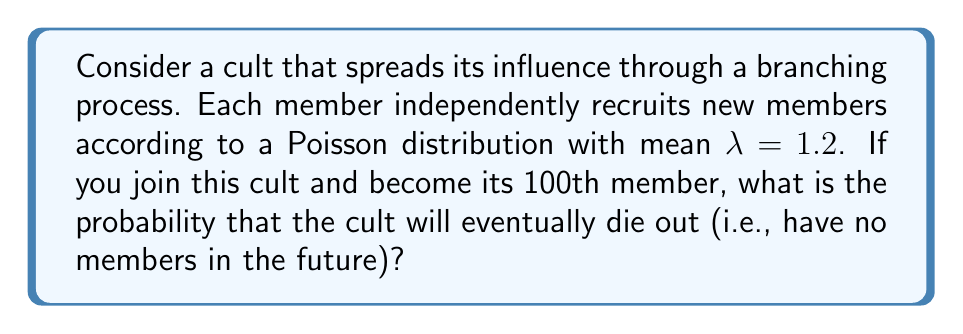Could you help me with this problem? To solve this problem, we'll use the theory of branching processes:

1) In a branching process, the probability of extinction is given by the smallest non-negative root of the equation:
   
   $$f(s) = G(s)$$

   where $G(s)$ is the probability generating function of the offspring distribution.

2) For a Poisson distribution with mean $\lambda$, the probability generating function is:
   
   $$G(s) = e^{\lambda(s-1)}$$

3) Therefore, we need to solve:
   
   $$s = e^{\lambda(s-1)}$$

4) With $\lambda = 1.2$, we have:
   
   $$s = e^{1.2(s-1)}$$

5) This equation can't be solved analytically, so we need to use numerical methods. Using a computer or calculator, we find that the smallest non-negative root is approximately:
   
   $$s \approx 0.7554$$

6) This value represents the probability that a single member's lineage will eventually die out.

7) However, the question asks about the probability of the entire cult dying out, given that you're the 100th member. This means there are already 99 other members.

8) The probability of the entire cult dying out is the probability that all 100 lineages (including yours) die out. This is:

   $$P(\text{extinction}) = (0.7554)^{100}$$

9) Calculate this value:
   
   $$P(\text{extinction}) \approx 1.0114 \times 10^{-11}$$
Answer: $1.0114 \times 10^{-11}$ 